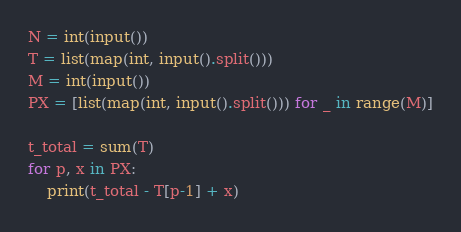Convert code to text. <code><loc_0><loc_0><loc_500><loc_500><_Python_>N = int(input())
T = list(map(int, input().split()))
M = int(input())
PX = [list(map(int, input().split())) for _ in range(M)]

t_total = sum(T)
for p, x in PX:
    print(t_total - T[p-1] + x)
</code> 